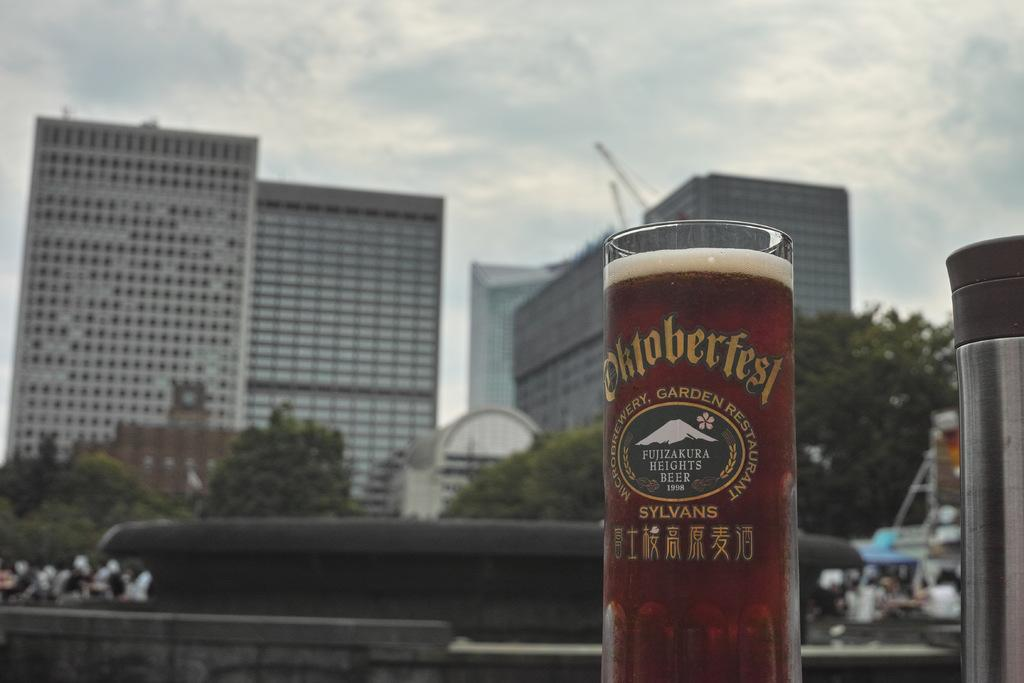Provide a one-sentence caption for the provided image. A tall beer glass with the words Oktoberfest written on it as the glass is filled with beer and city buildings are in the background. 